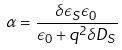Convert formula to latex. <formula><loc_0><loc_0><loc_500><loc_500>\alpha = \frac { \delta \epsilon _ { S } \epsilon _ { 0 } } { \epsilon _ { 0 } + q ^ { 2 } \delta D _ { S } }</formula> 